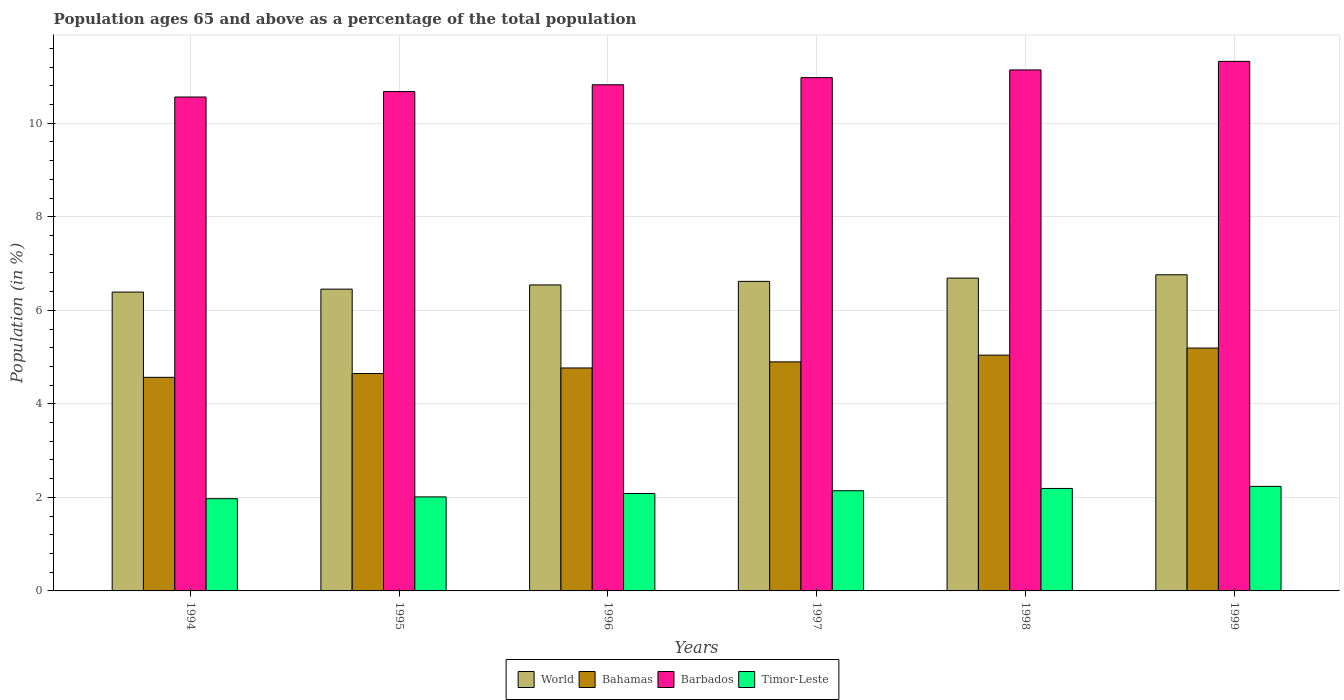How many different coloured bars are there?
Your response must be concise. 4. Are the number of bars per tick equal to the number of legend labels?
Offer a very short reply. Yes. What is the label of the 3rd group of bars from the left?
Give a very brief answer. 1996. What is the percentage of the population ages 65 and above in Timor-Leste in 1996?
Ensure brevity in your answer.  2.08. Across all years, what is the maximum percentage of the population ages 65 and above in World?
Offer a terse response. 6.76. Across all years, what is the minimum percentage of the population ages 65 and above in Bahamas?
Provide a succinct answer. 4.57. In which year was the percentage of the population ages 65 and above in Bahamas maximum?
Ensure brevity in your answer.  1999. What is the total percentage of the population ages 65 and above in Bahamas in the graph?
Make the answer very short. 29.11. What is the difference between the percentage of the population ages 65 and above in Timor-Leste in 1995 and that in 1996?
Provide a short and direct response. -0.07. What is the difference between the percentage of the population ages 65 and above in Timor-Leste in 1997 and the percentage of the population ages 65 and above in Barbados in 1995?
Give a very brief answer. -8.53. What is the average percentage of the population ages 65 and above in Timor-Leste per year?
Your answer should be compact. 2.11. In the year 1995, what is the difference between the percentage of the population ages 65 and above in Timor-Leste and percentage of the population ages 65 and above in World?
Ensure brevity in your answer.  -4.44. What is the ratio of the percentage of the population ages 65 and above in Barbados in 1995 to that in 1999?
Give a very brief answer. 0.94. Is the difference between the percentage of the population ages 65 and above in Timor-Leste in 1997 and 1998 greater than the difference between the percentage of the population ages 65 and above in World in 1997 and 1998?
Your answer should be very brief. Yes. What is the difference between the highest and the second highest percentage of the population ages 65 and above in Barbados?
Your answer should be compact. 0.18. What is the difference between the highest and the lowest percentage of the population ages 65 and above in Bahamas?
Ensure brevity in your answer.  0.63. Is it the case that in every year, the sum of the percentage of the population ages 65 and above in Bahamas and percentage of the population ages 65 and above in Barbados is greater than the sum of percentage of the population ages 65 and above in Timor-Leste and percentage of the population ages 65 and above in World?
Offer a very short reply. Yes. What does the 3rd bar from the left in 1994 represents?
Offer a terse response. Barbados. What does the 1st bar from the right in 1999 represents?
Keep it short and to the point. Timor-Leste. Is it the case that in every year, the sum of the percentage of the population ages 65 and above in Barbados and percentage of the population ages 65 and above in World is greater than the percentage of the population ages 65 and above in Timor-Leste?
Keep it short and to the point. Yes. How many bars are there?
Your answer should be very brief. 24. Are all the bars in the graph horizontal?
Your answer should be very brief. No. How many years are there in the graph?
Make the answer very short. 6. Does the graph contain any zero values?
Your answer should be very brief. No. Does the graph contain grids?
Offer a terse response. Yes. Where does the legend appear in the graph?
Provide a short and direct response. Bottom center. How many legend labels are there?
Your response must be concise. 4. How are the legend labels stacked?
Provide a short and direct response. Horizontal. What is the title of the graph?
Offer a very short reply. Population ages 65 and above as a percentage of the total population. What is the label or title of the Y-axis?
Give a very brief answer. Population (in %). What is the Population (in %) of World in 1994?
Make the answer very short. 6.39. What is the Population (in %) of Bahamas in 1994?
Provide a succinct answer. 4.57. What is the Population (in %) in Barbados in 1994?
Provide a short and direct response. 10.56. What is the Population (in %) of Timor-Leste in 1994?
Provide a succinct answer. 1.97. What is the Population (in %) in World in 1995?
Your response must be concise. 6.45. What is the Population (in %) of Bahamas in 1995?
Your response must be concise. 4.65. What is the Population (in %) in Barbados in 1995?
Offer a very short reply. 10.68. What is the Population (in %) in Timor-Leste in 1995?
Give a very brief answer. 2.01. What is the Population (in %) in World in 1996?
Offer a terse response. 6.54. What is the Population (in %) of Bahamas in 1996?
Your response must be concise. 4.77. What is the Population (in %) of Barbados in 1996?
Provide a succinct answer. 10.82. What is the Population (in %) in Timor-Leste in 1996?
Your response must be concise. 2.08. What is the Population (in %) in World in 1997?
Ensure brevity in your answer.  6.62. What is the Population (in %) of Bahamas in 1997?
Ensure brevity in your answer.  4.9. What is the Population (in %) of Barbados in 1997?
Your response must be concise. 10.97. What is the Population (in %) in Timor-Leste in 1997?
Make the answer very short. 2.14. What is the Population (in %) in World in 1998?
Offer a very short reply. 6.69. What is the Population (in %) of Bahamas in 1998?
Make the answer very short. 5.04. What is the Population (in %) in Barbados in 1998?
Provide a succinct answer. 11.14. What is the Population (in %) of Timor-Leste in 1998?
Your answer should be compact. 2.19. What is the Population (in %) in World in 1999?
Provide a short and direct response. 6.76. What is the Population (in %) of Bahamas in 1999?
Keep it short and to the point. 5.19. What is the Population (in %) of Barbados in 1999?
Give a very brief answer. 11.32. What is the Population (in %) of Timor-Leste in 1999?
Offer a very short reply. 2.24. Across all years, what is the maximum Population (in %) in World?
Provide a short and direct response. 6.76. Across all years, what is the maximum Population (in %) of Bahamas?
Ensure brevity in your answer.  5.19. Across all years, what is the maximum Population (in %) in Barbados?
Give a very brief answer. 11.32. Across all years, what is the maximum Population (in %) of Timor-Leste?
Offer a very short reply. 2.24. Across all years, what is the minimum Population (in %) in World?
Offer a very short reply. 6.39. Across all years, what is the minimum Population (in %) of Bahamas?
Give a very brief answer. 4.57. Across all years, what is the minimum Population (in %) of Barbados?
Give a very brief answer. 10.56. Across all years, what is the minimum Population (in %) of Timor-Leste?
Provide a short and direct response. 1.97. What is the total Population (in %) in World in the graph?
Give a very brief answer. 39.45. What is the total Population (in %) in Bahamas in the graph?
Ensure brevity in your answer.  29.11. What is the total Population (in %) in Barbados in the graph?
Your answer should be very brief. 65.5. What is the total Population (in %) of Timor-Leste in the graph?
Your answer should be compact. 12.63. What is the difference between the Population (in %) of World in 1994 and that in 1995?
Provide a succinct answer. -0.06. What is the difference between the Population (in %) of Bahamas in 1994 and that in 1995?
Provide a short and direct response. -0.08. What is the difference between the Population (in %) of Barbados in 1994 and that in 1995?
Offer a very short reply. -0.12. What is the difference between the Population (in %) in Timor-Leste in 1994 and that in 1995?
Provide a short and direct response. -0.04. What is the difference between the Population (in %) in World in 1994 and that in 1996?
Keep it short and to the point. -0.15. What is the difference between the Population (in %) of Bahamas in 1994 and that in 1996?
Your response must be concise. -0.2. What is the difference between the Population (in %) in Barbados in 1994 and that in 1996?
Offer a very short reply. -0.26. What is the difference between the Population (in %) in Timor-Leste in 1994 and that in 1996?
Ensure brevity in your answer.  -0.11. What is the difference between the Population (in %) in World in 1994 and that in 1997?
Offer a terse response. -0.23. What is the difference between the Population (in %) of Bahamas in 1994 and that in 1997?
Provide a short and direct response. -0.33. What is the difference between the Population (in %) of Barbados in 1994 and that in 1997?
Make the answer very short. -0.41. What is the difference between the Population (in %) in Timor-Leste in 1994 and that in 1997?
Your response must be concise. -0.17. What is the difference between the Population (in %) of World in 1994 and that in 1998?
Ensure brevity in your answer.  -0.3. What is the difference between the Population (in %) in Bahamas in 1994 and that in 1998?
Give a very brief answer. -0.47. What is the difference between the Population (in %) in Barbados in 1994 and that in 1998?
Your answer should be compact. -0.58. What is the difference between the Population (in %) in Timor-Leste in 1994 and that in 1998?
Provide a succinct answer. -0.22. What is the difference between the Population (in %) of World in 1994 and that in 1999?
Make the answer very short. -0.37. What is the difference between the Population (in %) in Bahamas in 1994 and that in 1999?
Your answer should be compact. -0.63. What is the difference between the Population (in %) in Barbados in 1994 and that in 1999?
Provide a short and direct response. -0.76. What is the difference between the Population (in %) in Timor-Leste in 1994 and that in 1999?
Your response must be concise. -0.26. What is the difference between the Population (in %) in World in 1995 and that in 1996?
Provide a succinct answer. -0.09. What is the difference between the Population (in %) in Bahamas in 1995 and that in 1996?
Offer a very short reply. -0.12. What is the difference between the Population (in %) of Barbados in 1995 and that in 1996?
Your answer should be very brief. -0.15. What is the difference between the Population (in %) in Timor-Leste in 1995 and that in 1996?
Offer a very short reply. -0.07. What is the difference between the Population (in %) in World in 1995 and that in 1997?
Make the answer very short. -0.17. What is the difference between the Population (in %) of Bahamas in 1995 and that in 1997?
Your answer should be very brief. -0.25. What is the difference between the Population (in %) of Barbados in 1995 and that in 1997?
Give a very brief answer. -0.3. What is the difference between the Population (in %) of Timor-Leste in 1995 and that in 1997?
Give a very brief answer. -0.13. What is the difference between the Population (in %) in World in 1995 and that in 1998?
Your answer should be compact. -0.24. What is the difference between the Population (in %) in Bahamas in 1995 and that in 1998?
Your answer should be compact. -0.39. What is the difference between the Population (in %) of Barbados in 1995 and that in 1998?
Provide a succinct answer. -0.46. What is the difference between the Population (in %) in Timor-Leste in 1995 and that in 1998?
Your answer should be compact. -0.18. What is the difference between the Population (in %) of World in 1995 and that in 1999?
Provide a succinct answer. -0.31. What is the difference between the Population (in %) in Bahamas in 1995 and that in 1999?
Provide a short and direct response. -0.54. What is the difference between the Population (in %) of Barbados in 1995 and that in 1999?
Your answer should be compact. -0.65. What is the difference between the Population (in %) in Timor-Leste in 1995 and that in 1999?
Provide a succinct answer. -0.23. What is the difference between the Population (in %) in World in 1996 and that in 1997?
Keep it short and to the point. -0.08. What is the difference between the Population (in %) in Bahamas in 1996 and that in 1997?
Keep it short and to the point. -0.13. What is the difference between the Population (in %) in Barbados in 1996 and that in 1997?
Give a very brief answer. -0.15. What is the difference between the Population (in %) in Timor-Leste in 1996 and that in 1997?
Keep it short and to the point. -0.06. What is the difference between the Population (in %) in World in 1996 and that in 1998?
Keep it short and to the point. -0.15. What is the difference between the Population (in %) of Bahamas in 1996 and that in 1998?
Offer a very short reply. -0.27. What is the difference between the Population (in %) in Barbados in 1996 and that in 1998?
Give a very brief answer. -0.32. What is the difference between the Population (in %) of Timor-Leste in 1996 and that in 1998?
Keep it short and to the point. -0.11. What is the difference between the Population (in %) in World in 1996 and that in 1999?
Ensure brevity in your answer.  -0.22. What is the difference between the Population (in %) of Bahamas in 1996 and that in 1999?
Offer a very short reply. -0.43. What is the difference between the Population (in %) in Barbados in 1996 and that in 1999?
Offer a very short reply. -0.5. What is the difference between the Population (in %) of Timor-Leste in 1996 and that in 1999?
Offer a terse response. -0.15. What is the difference between the Population (in %) of World in 1997 and that in 1998?
Give a very brief answer. -0.07. What is the difference between the Population (in %) of Bahamas in 1997 and that in 1998?
Your answer should be compact. -0.14. What is the difference between the Population (in %) of Barbados in 1997 and that in 1998?
Make the answer very short. -0.16. What is the difference between the Population (in %) in Timor-Leste in 1997 and that in 1998?
Your answer should be compact. -0.05. What is the difference between the Population (in %) of World in 1997 and that in 1999?
Your answer should be compact. -0.14. What is the difference between the Population (in %) of Bahamas in 1997 and that in 1999?
Offer a very short reply. -0.3. What is the difference between the Population (in %) of Barbados in 1997 and that in 1999?
Ensure brevity in your answer.  -0.35. What is the difference between the Population (in %) in Timor-Leste in 1997 and that in 1999?
Your answer should be very brief. -0.09. What is the difference between the Population (in %) in World in 1998 and that in 1999?
Offer a terse response. -0.07. What is the difference between the Population (in %) of Bahamas in 1998 and that in 1999?
Your answer should be compact. -0.15. What is the difference between the Population (in %) in Barbados in 1998 and that in 1999?
Offer a very short reply. -0.18. What is the difference between the Population (in %) of Timor-Leste in 1998 and that in 1999?
Offer a very short reply. -0.04. What is the difference between the Population (in %) in World in 1994 and the Population (in %) in Bahamas in 1995?
Ensure brevity in your answer.  1.74. What is the difference between the Population (in %) in World in 1994 and the Population (in %) in Barbados in 1995?
Offer a terse response. -4.29. What is the difference between the Population (in %) in World in 1994 and the Population (in %) in Timor-Leste in 1995?
Ensure brevity in your answer.  4.38. What is the difference between the Population (in %) in Bahamas in 1994 and the Population (in %) in Barbados in 1995?
Your response must be concise. -6.11. What is the difference between the Population (in %) in Bahamas in 1994 and the Population (in %) in Timor-Leste in 1995?
Provide a succinct answer. 2.56. What is the difference between the Population (in %) in Barbados in 1994 and the Population (in %) in Timor-Leste in 1995?
Make the answer very short. 8.55. What is the difference between the Population (in %) of World in 1994 and the Population (in %) of Bahamas in 1996?
Keep it short and to the point. 1.62. What is the difference between the Population (in %) in World in 1994 and the Population (in %) in Barbados in 1996?
Offer a terse response. -4.43. What is the difference between the Population (in %) of World in 1994 and the Population (in %) of Timor-Leste in 1996?
Make the answer very short. 4.31. What is the difference between the Population (in %) in Bahamas in 1994 and the Population (in %) in Barbados in 1996?
Your answer should be very brief. -6.26. What is the difference between the Population (in %) in Bahamas in 1994 and the Population (in %) in Timor-Leste in 1996?
Make the answer very short. 2.48. What is the difference between the Population (in %) in Barbados in 1994 and the Population (in %) in Timor-Leste in 1996?
Ensure brevity in your answer.  8.48. What is the difference between the Population (in %) of World in 1994 and the Population (in %) of Bahamas in 1997?
Your answer should be very brief. 1.49. What is the difference between the Population (in %) in World in 1994 and the Population (in %) in Barbados in 1997?
Ensure brevity in your answer.  -4.59. What is the difference between the Population (in %) in World in 1994 and the Population (in %) in Timor-Leste in 1997?
Offer a terse response. 4.25. What is the difference between the Population (in %) of Bahamas in 1994 and the Population (in %) of Barbados in 1997?
Provide a succinct answer. -6.41. What is the difference between the Population (in %) of Bahamas in 1994 and the Population (in %) of Timor-Leste in 1997?
Keep it short and to the point. 2.42. What is the difference between the Population (in %) in Barbados in 1994 and the Population (in %) in Timor-Leste in 1997?
Offer a terse response. 8.42. What is the difference between the Population (in %) in World in 1994 and the Population (in %) in Bahamas in 1998?
Keep it short and to the point. 1.35. What is the difference between the Population (in %) of World in 1994 and the Population (in %) of Barbados in 1998?
Offer a very short reply. -4.75. What is the difference between the Population (in %) in World in 1994 and the Population (in %) in Timor-Leste in 1998?
Make the answer very short. 4.2. What is the difference between the Population (in %) in Bahamas in 1994 and the Population (in %) in Barbados in 1998?
Your answer should be compact. -6.57. What is the difference between the Population (in %) of Bahamas in 1994 and the Population (in %) of Timor-Leste in 1998?
Provide a short and direct response. 2.38. What is the difference between the Population (in %) in Barbados in 1994 and the Population (in %) in Timor-Leste in 1998?
Your answer should be very brief. 8.37. What is the difference between the Population (in %) in World in 1994 and the Population (in %) in Bahamas in 1999?
Ensure brevity in your answer.  1.2. What is the difference between the Population (in %) of World in 1994 and the Population (in %) of Barbados in 1999?
Your answer should be very brief. -4.93. What is the difference between the Population (in %) in World in 1994 and the Population (in %) in Timor-Leste in 1999?
Your response must be concise. 4.15. What is the difference between the Population (in %) in Bahamas in 1994 and the Population (in %) in Barbados in 1999?
Make the answer very short. -6.76. What is the difference between the Population (in %) of Bahamas in 1994 and the Population (in %) of Timor-Leste in 1999?
Ensure brevity in your answer.  2.33. What is the difference between the Population (in %) in Barbados in 1994 and the Population (in %) in Timor-Leste in 1999?
Make the answer very short. 8.32. What is the difference between the Population (in %) of World in 1995 and the Population (in %) of Bahamas in 1996?
Offer a very short reply. 1.69. What is the difference between the Population (in %) in World in 1995 and the Population (in %) in Barbados in 1996?
Keep it short and to the point. -4.37. What is the difference between the Population (in %) of World in 1995 and the Population (in %) of Timor-Leste in 1996?
Provide a short and direct response. 4.37. What is the difference between the Population (in %) of Bahamas in 1995 and the Population (in %) of Barbados in 1996?
Ensure brevity in your answer.  -6.17. What is the difference between the Population (in %) in Bahamas in 1995 and the Population (in %) in Timor-Leste in 1996?
Offer a terse response. 2.57. What is the difference between the Population (in %) of Barbados in 1995 and the Population (in %) of Timor-Leste in 1996?
Provide a short and direct response. 8.59. What is the difference between the Population (in %) in World in 1995 and the Population (in %) in Bahamas in 1997?
Offer a terse response. 1.56. What is the difference between the Population (in %) of World in 1995 and the Population (in %) of Barbados in 1997?
Provide a succinct answer. -4.52. What is the difference between the Population (in %) of World in 1995 and the Population (in %) of Timor-Leste in 1997?
Your response must be concise. 4.31. What is the difference between the Population (in %) in Bahamas in 1995 and the Population (in %) in Barbados in 1997?
Provide a succinct answer. -6.33. What is the difference between the Population (in %) in Bahamas in 1995 and the Population (in %) in Timor-Leste in 1997?
Your answer should be compact. 2.51. What is the difference between the Population (in %) in Barbados in 1995 and the Population (in %) in Timor-Leste in 1997?
Offer a terse response. 8.53. What is the difference between the Population (in %) in World in 1995 and the Population (in %) in Bahamas in 1998?
Provide a succinct answer. 1.41. What is the difference between the Population (in %) in World in 1995 and the Population (in %) in Barbados in 1998?
Offer a terse response. -4.69. What is the difference between the Population (in %) of World in 1995 and the Population (in %) of Timor-Leste in 1998?
Your answer should be very brief. 4.26. What is the difference between the Population (in %) of Bahamas in 1995 and the Population (in %) of Barbados in 1998?
Provide a succinct answer. -6.49. What is the difference between the Population (in %) of Bahamas in 1995 and the Population (in %) of Timor-Leste in 1998?
Your response must be concise. 2.46. What is the difference between the Population (in %) in Barbados in 1995 and the Population (in %) in Timor-Leste in 1998?
Keep it short and to the point. 8.49. What is the difference between the Population (in %) of World in 1995 and the Population (in %) of Bahamas in 1999?
Give a very brief answer. 1.26. What is the difference between the Population (in %) of World in 1995 and the Population (in %) of Barbados in 1999?
Provide a short and direct response. -4.87. What is the difference between the Population (in %) of World in 1995 and the Population (in %) of Timor-Leste in 1999?
Provide a short and direct response. 4.22. What is the difference between the Population (in %) of Bahamas in 1995 and the Population (in %) of Barbados in 1999?
Ensure brevity in your answer.  -6.67. What is the difference between the Population (in %) of Bahamas in 1995 and the Population (in %) of Timor-Leste in 1999?
Offer a very short reply. 2.41. What is the difference between the Population (in %) in Barbados in 1995 and the Population (in %) in Timor-Leste in 1999?
Keep it short and to the point. 8.44. What is the difference between the Population (in %) in World in 1996 and the Population (in %) in Bahamas in 1997?
Give a very brief answer. 1.64. What is the difference between the Population (in %) of World in 1996 and the Population (in %) of Barbados in 1997?
Offer a very short reply. -4.43. What is the difference between the Population (in %) of World in 1996 and the Population (in %) of Timor-Leste in 1997?
Ensure brevity in your answer.  4.4. What is the difference between the Population (in %) of Bahamas in 1996 and the Population (in %) of Barbados in 1997?
Ensure brevity in your answer.  -6.21. What is the difference between the Population (in %) in Bahamas in 1996 and the Population (in %) in Timor-Leste in 1997?
Your answer should be very brief. 2.63. What is the difference between the Population (in %) in Barbados in 1996 and the Population (in %) in Timor-Leste in 1997?
Offer a terse response. 8.68. What is the difference between the Population (in %) of World in 1996 and the Population (in %) of Bahamas in 1998?
Provide a succinct answer. 1.5. What is the difference between the Population (in %) of World in 1996 and the Population (in %) of Barbados in 1998?
Your answer should be very brief. -4.6. What is the difference between the Population (in %) of World in 1996 and the Population (in %) of Timor-Leste in 1998?
Your answer should be very brief. 4.35. What is the difference between the Population (in %) in Bahamas in 1996 and the Population (in %) in Barbados in 1998?
Make the answer very short. -6.37. What is the difference between the Population (in %) in Bahamas in 1996 and the Population (in %) in Timor-Leste in 1998?
Make the answer very short. 2.58. What is the difference between the Population (in %) of Barbados in 1996 and the Population (in %) of Timor-Leste in 1998?
Your answer should be very brief. 8.63. What is the difference between the Population (in %) of World in 1996 and the Population (in %) of Bahamas in 1999?
Your response must be concise. 1.35. What is the difference between the Population (in %) of World in 1996 and the Population (in %) of Barbados in 1999?
Your response must be concise. -4.78. What is the difference between the Population (in %) of World in 1996 and the Population (in %) of Timor-Leste in 1999?
Your response must be concise. 4.31. What is the difference between the Population (in %) of Bahamas in 1996 and the Population (in %) of Barbados in 1999?
Provide a short and direct response. -6.56. What is the difference between the Population (in %) in Bahamas in 1996 and the Population (in %) in Timor-Leste in 1999?
Ensure brevity in your answer.  2.53. What is the difference between the Population (in %) of Barbados in 1996 and the Population (in %) of Timor-Leste in 1999?
Provide a short and direct response. 8.59. What is the difference between the Population (in %) of World in 1997 and the Population (in %) of Bahamas in 1998?
Ensure brevity in your answer.  1.58. What is the difference between the Population (in %) in World in 1997 and the Population (in %) in Barbados in 1998?
Make the answer very short. -4.52. What is the difference between the Population (in %) in World in 1997 and the Population (in %) in Timor-Leste in 1998?
Give a very brief answer. 4.43. What is the difference between the Population (in %) in Bahamas in 1997 and the Population (in %) in Barbados in 1998?
Ensure brevity in your answer.  -6.24. What is the difference between the Population (in %) in Bahamas in 1997 and the Population (in %) in Timor-Leste in 1998?
Make the answer very short. 2.71. What is the difference between the Population (in %) of Barbados in 1997 and the Population (in %) of Timor-Leste in 1998?
Ensure brevity in your answer.  8.78. What is the difference between the Population (in %) in World in 1997 and the Population (in %) in Bahamas in 1999?
Your response must be concise. 1.43. What is the difference between the Population (in %) in World in 1997 and the Population (in %) in Barbados in 1999?
Your response must be concise. -4.7. What is the difference between the Population (in %) of World in 1997 and the Population (in %) of Timor-Leste in 1999?
Make the answer very short. 4.38. What is the difference between the Population (in %) of Bahamas in 1997 and the Population (in %) of Barbados in 1999?
Your response must be concise. -6.43. What is the difference between the Population (in %) of Bahamas in 1997 and the Population (in %) of Timor-Leste in 1999?
Your response must be concise. 2.66. What is the difference between the Population (in %) in Barbados in 1997 and the Population (in %) in Timor-Leste in 1999?
Offer a very short reply. 8.74. What is the difference between the Population (in %) in World in 1998 and the Population (in %) in Bahamas in 1999?
Make the answer very short. 1.5. What is the difference between the Population (in %) of World in 1998 and the Population (in %) of Barbados in 1999?
Your answer should be compact. -4.63. What is the difference between the Population (in %) of World in 1998 and the Population (in %) of Timor-Leste in 1999?
Your answer should be very brief. 4.45. What is the difference between the Population (in %) in Bahamas in 1998 and the Population (in %) in Barbados in 1999?
Give a very brief answer. -6.28. What is the difference between the Population (in %) of Bahamas in 1998 and the Population (in %) of Timor-Leste in 1999?
Provide a succinct answer. 2.81. What is the difference between the Population (in %) of Barbados in 1998 and the Population (in %) of Timor-Leste in 1999?
Your answer should be very brief. 8.9. What is the average Population (in %) of World per year?
Make the answer very short. 6.58. What is the average Population (in %) in Bahamas per year?
Give a very brief answer. 4.85. What is the average Population (in %) in Barbados per year?
Ensure brevity in your answer.  10.92. What is the average Population (in %) of Timor-Leste per year?
Give a very brief answer. 2.11. In the year 1994, what is the difference between the Population (in %) of World and Population (in %) of Bahamas?
Make the answer very short. 1.82. In the year 1994, what is the difference between the Population (in %) of World and Population (in %) of Barbados?
Offer a very short reply. -4.17. In the year 1994, what is the difference between the Population (in %) in World and Population (in %) in Timor-Leste?
Your answer should be very brief. 4.42. In the year 1994, what is the difference between the Population (in %) of Bahamas and Population (in %) of Barbados?
Your answer should be very brief. -5.99. In the year 1994, what is the difference between the Population (in %) of Bahamas and Population (in %) of Timor-Leste?
Your answer should be very brief. 2.59. In the year 1994, what is the difference between the Population (in %) of Barbados and Population (in %) of Timor-Leste?
Your answer should be compact. 8.59. In the year 1995, what is the difference between the Population (in %) of World and Population (in %) of Bahamas?
Your answer should be very brief. 1.8. In the year 1995, what is the difference between the Population (in %) in World and Population (in %) in Barbados?
Keep it short and to the point. -4.22. In the year 1995, what is the difference between the Population (in %) of World and Population (in %) of Timor-Leste?
Provide a succinct answer. 4.44. In the year 1995, what is the difference between the Population (in %) of Bahamas and Population (in %) of Barbados?
Your answer should be compact. -6.03. In the year 1995, what is the difference between the Population (in %) of Bahamas and Population (in %) of Timor-Leste?
Give a very brief answer. 2.64. In the year 1995, what is the difference between the Population (in %) of Barbados and Population (in %) of Timor-Leste?
Offer a very short reply. 8.67. In the year 1996, what is the difference between the Population (in %) of World and Population (in %) of Bahamas?
Keep it short and to the point. 1.77. In the year 1996, what is the difference between the Population (in %) of World and Population (in %) of Barbados?
Give a very brief answer. -4.28. In the year 1996, what is the difference between the Population (in %) of World and Population (in %) of Timor-Leste?
Provide a succinct answer. 4.46. In the year 1996, what is the difference between the Population (in %) of Bahamas and Population (in %) of Barbados?
Offer a very short reply. -6.05. In the year 1996, what is the difference between the Population (in %) of Bahamas and Population (in %) of Timor-Leste?
Make the answer very short. 2.68. In the year 1996, what is the difference between the Population (in %) of Barbados and Population (in %) of Timor-Leste?
Offer a terse response. 8.74. In the year 1997, what is the difference between the Population (in %) of World and Population (in %) of Bahamas?
Offer a terse response. 1.72. In the year 1997, what is the difference between the Population (in %) of World and Population (in %) of Barbados?
Your response must be concise. -4.36. In the year 1997, what is the difference between the Population (in %) of World and Population (in %) of Timor-Leste?
Your answer should be compact. 4.48. In the year 1997, what is the difference between the Population (in %) of Bahamas and Population (in %) of Barbados?
Provide a short and direct response. -6.08. In the year 1997, what is the difference between the Population (in %) in Bahamas and Population (in %) in Timor-Leste?
Make the answer very short. 2.76. In the year 1997, what is the difference between the Population (in %) of Barbados and Population (in %) of Timor-Leste?
Give a very brief answer. 8.83. In the year 1998, what is the difference between the Population (in %) in World and Population (in %) in Bahamas?
Keep it short and to the point. 1.65. In the year 1998, what is the difference between the Population (in %) in World and Population (in %) in Barbados?
Give a very brief answer. -4.45. In the year 1998, what is the difference between the Population (in %) of World and Population (in %) of Timor-Leste?
Offer a very short reply. 4.5. In the year 1998, what is the difference between the Population (in %) of Bahamas and Population (in %) of Barbados?
Your response must be concise. -6.1. In the year 1998, what is the difference between the Population (in %) in Bahamas and Population (in %) in Timor-Leste?
Your response must be concise. 2.85. In the year 1998, what is the difference between the Population (in %) in Barbados and Population (in %) in Timor-Leste?
Provide a short and direct response. 8.95. In the year 1999, what is the difference between the Population (in %) of World and Population (in %) of Bahamas?
Offer a terse response. 1.57. In the year 1999, what is the difference between the Population (in %) of World and Population (in %) of Barbados?
Your response must be concise. -4.56. In the year 1999, what is the difference between the Population (in %) of World and Population (in %) of Timor-Leste?
Keep it short and to the point. 4.52. In the year 1999, what is the difference between the Population (in %) in Bahamas and Population (in %) in Barbados?
Your answer should be very brief. -6.13. In the year 1999, what is the difference between the Population (in %) of Bahamas and Population (in %) of Timor-Leste?
Give a very brief answer. 2.96. In the year 1999, what is the difference between the Population (in %) in Barbados and Population (in %) in Timor-Leste?
Make the answer very short. 9.09. What is the ratio of the Population (in %) of World in 1994 to that in 1995?
Make the answer very short. 0.99. What is the ratio of the Population (in %) in Bahamas in 1994 to that in 1995?
Offer a very short reply. 0.98. What is the ratio of the Population (in %) in Barbados in 1994 to that in 1995?
Your answer should be very brief. 0.99. What is the ratio of the Population (in %) in Timor-Leste in 1994 to that in 1995?
Your response must be concise. 0.98. What is the ratio of the Population (in %) of World in 1994 to that in 1996?
Keep it short and to the point. 0.98. What is the ratio of the Population (in %) of Bahamas in 1994 to that in 1996?
Your response must be concise. 0.96. What is the ratio of the Population (in %) of Barbados in 1994 to that in 1996?
Give a very brief answer. 0.98. What is the ratio of the Population (in %) in Timor-Leste in 1994 to that in 1996?
Offer a terse response. 0.95. What is the ratio of the Population (in %) in World in 1994 to that in 1997?
Make the answer very short. 0.97. What is the ratio of the Population (in %) in Bahamas in 1994 to that in 1997?
Offer a terse response. 0.93. What is the ratio of the Population (in %) of Barbados in 1994 to that in 1997?
Provide a short and direct response. 0.96. What is the ratio of the Population (in %) in Timor-Leste in 1994 to that in 1997?
Provide a short and direct response. 0.92. What is the ratio of the Population (in %) of World in 1994 to that in 1998?
Make the answer very short. 0.96. What is the ratio of the Population (in %) in Bahamas in 1994 to that in 1998?
Provide a short and direct response. 0.91. What is the ratio of the Population (in %) of Barbados in 1994 to that in 1998?
Keep it short and to the point. 0.95. What is the ratio of the Population (in %) in World in 1994 to that in 1999?
Make the answer very short. 0.95. What is the ratio of the Population (in %) of Bahamas in 1994 to that in 1999?
Your answer should be very brief. 0.88. What is the ratio of the Population (in %) in Barbados in 1994 to that in 1999?
Keep it short and to the point. 0.93. What is the ratio of the Population (in %) of Timor-Leste in 1994 to that in 1999?
Your response must be concise. 0.88. What is the ratio of the Population (in %) of World in 1995 to that in 1996?
Make the answer very short. 0.99. What is the ratio of the Population (in %) of Barbados in 1995 to that in 1996?
Make the answer very short. 0.99. What is the ratio of the Population (in %) in Timor-Leste in 1995 to that in 1996?
Your response must be concise. 0.97. What is the ratio of the Population (in %) of World in 1995 to that in 1997?
Offer a very short reply. 0.97. What is the ratio of the Population (in %) in Bahamas in 1995 to that in 1997?
Provide a short and direct response. 0.95. What is the ratio of the Population (in %) of Barbados in 1995 to that in 1997?
Provide a short and direct response. 0.97. What is the ratio of the Population (in %) in Timor-Leste in 1995 to that in 1997?
Provide a short and direct response. 0.94. What is the ratio of the Population (in %) in World in 1995 to that in 1998?
Offer a terse response. 0.96. What is the ratio of the Population (in %) of Bahamas in 1995 to that in 1998?
Your answer should be compact. 0.92. What is the ratio of the Population (in %) of Barbados in 1995 to that in 1998?
Make the answer very short. 0.96. What is the ratio of the Population (in %) of Timor-Leste in 1995 to that in 1998?
Your answer should be very brief. 0.92. What is the ratio of the Population (in %) in World in 1995 to that in 1999?
Your answer should be very brief. 0.95. What is the ratio of the Population (in %) in Bahamas in 1995 to that in 1999?
Keep it short and to the point. 0.9. What is the ratio of the Population (in %) in Barbados in 1995 to that in 1999?
Your response must be concise. 0.94. What is the ratio of the Population (in %) in Timor-Leste in 1995 to that in 1999?
Provide a succinct answer. 0.9. What is the ratio of the Population (in %) in World in 1996 to that in 1997?
Offer a terse response. 0.99. What is the ratio of the Population (in %) of Bahamas in 1996 to that in 1997?
Your response must be concise. 0.97. What is the ratio of the Population (in %) of Barbados in 1996 to that in 1997?
Provide a succinct answer. 0.99. What is the ratio of the Population (in %) in Timor-Leste in 1996 to that in 1997?
Offer a terse response. 0.97. What is the ratio of the Population (in %) in World in 1996 to that in 1998?
Make the answer very short. 0.98. What is the ratio of the Population (in %) in Bahamas in 1996 to that in 1998?
Provide a succinct answer. 0.95. What is the ratio of the Population (in %) of Barbados in 1996 to that in 1998?
Your answer should be compact. 0.97. What is the ratio of the Population (in %) in Timor-Leste in 1996 to that in 1998?
Offer a very short reply. 0.95. What is the ratio of the Population (in %) in World in 1996 to that in 1999?
Ensure brevity in your answer.  0.97. What is the ratio of the Population (in %) in Bahamas in 1996 to that in 1999?
Keep it short and to the point. 0.92. What is the ratio of the Population (in %) of Barbados in 1996 to that in 1999?
Your answer should be compact. 0.96. What is the ratio of the Population (in %) of Timor-Leste in 1996 to that in 1999?
Your response must be concise. 0.93. What is the ratio of the Population (in %) in World in 1997 to that in 1998?
Your answer should be very brief. 0.99. What is the ratio of the Population (in %) in Bahamas in 1997 to that in 1998?
Give a very brief answer. 0.97. What is the ratio of the Population (in %) in Barbados in 1997 to that in 1998?
Provide a short and direct response. 0.99. What is the ratio of the Population (in %) in Timor-Leste in 1997 to that in 1998?
Your response must be concise. 0.98. What is the ratio of the Population (in %) of World in 1997 to that in 1999?
Offer a very short reply. 0.98. What is the ratio of the Population (in %) of Bahamas in 1997 to that in 1999?
Give a very brief answer. 0.94. What is the ratio of the Population (in %) of Barbados in 1997 to that in 1999?
Keep it short and to the point. 0.97. What is the ratio of the Population (in %) in Timor-Leste in 1997 to that in 1999?
Ensure brevity in your answer.  0.96. What is the ratio of the Population (in %) in Bahamas in 1998 to that in 1999?
Your response must be concise. 0.97. What is the ratio of the Population (in %) in Barbados in 1998 to that in 1999?
Make the answer very short. 0.98. What is the ratio of the Population (in %) in Timor-Leste in 1998 to that in 1999?
Make the answer very short. 0.98. What is the difference between the highest and the second highest Population (in %) in World?
Your answer should be compact. 0.07. What is the difference between the highest and the second highest Population (in %) of Bahamas?
Give a very brief answer. 0.15. What is the difference between the highest and the second highest Population (in %) of Barbados?
Keep it short and to the point. 0.18. What is the difference between the highest and the second highest Population (in %) in Timor-Leste?
Ensure brevity in your answer.  0.04. What is the difference between the highest and the lowest Population (in %) in World?
Offer a very short reply. 0.37. What is the difference between the highest and the lowest Population (in %) of Bahamas?
Give a very brief answer. 0.63. What is the difference between the highest and the lowest Population (in %) in Barbados?
Ensure brevity in your answer.  0.76. What is the difference between the highest and the lowest Population (in %) of Timor-Leste?
Offer a very short reply. 0.26. 